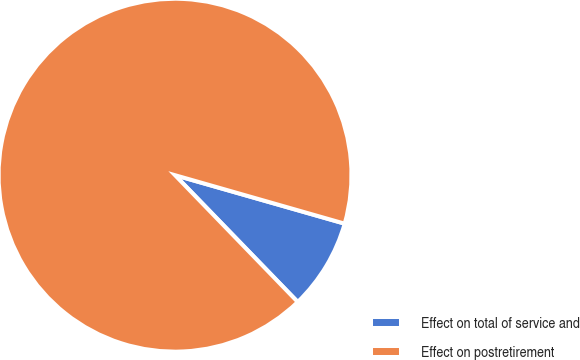<chart> <loc_0><loc_0><loc_500><loc_500><pie_chart><fcel>Effect on total of service and<fcel>Effect on postretirement<nl><fcel>8.33%<fcel>91.67%<nl></chart> 